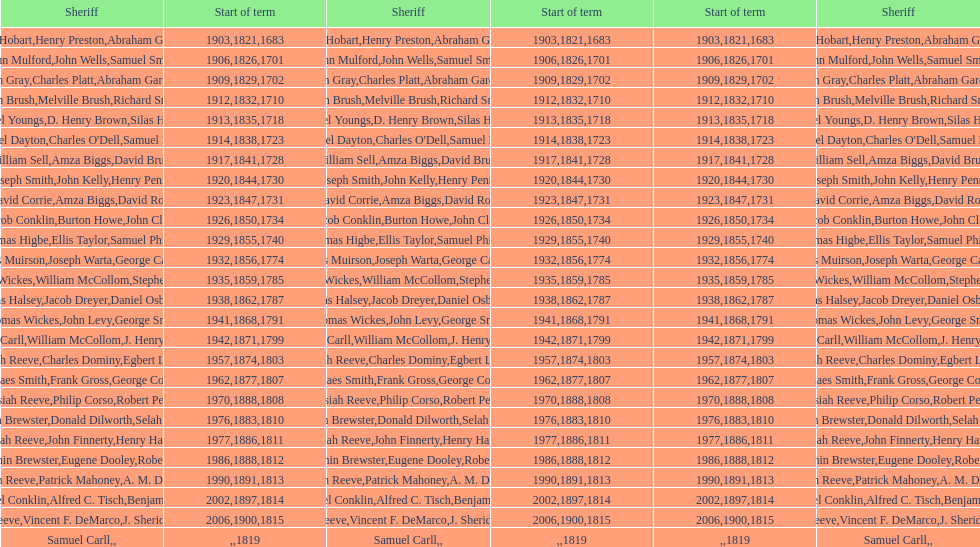Who was the sheriff in suffolk county before amza biggs first term there as sheriff? Charles O'Dell. Would you mind parsing the complete table? {'header': ['Sheriff', 'Start of term', 'Sheriff', 'Start of term', 'Start of term', 'Sheriff'], 'rows': [['Josiah Hobart', '1903', 'Henry Preston', '1821', '1683', 'Abraham Gardiner'], ['John Mulford', '1906', 'John Wells', '1826', '1701', 'Samuel Smith'], ['Hugh Gray', '1909', 'Charles Platt', '1829', '1702', 'Abraham Gardiner'], ['John Brush', '1912', 'Melville Brush', '1832', '1710', 'Richard Smith'], ['Daniel Youngs', '1913', 'D. Henry Brown', '1835', '1718', 'Silas Horton'], ['Samuel Dayton', '1914', "Charles O'Dell", '1838', '1723', 'Samuel Miller'], ['William Sell', '1917', 'Amza Biggs', '1841', '1728', 'David Brush'], ['Joseph Smith', '1920', 'John Kelly', '1844', '1730', 'Henry Penny'], ['David Corrie', '1923', 'Amza Biggs', '1847', '1731', 'David Rose'], ['Jacob Conklin', '1926', 'Burton Howe', '1850', '1734', 'John Clark'], ['Thomas Higbe', '1929', 'Ellis Taylor', '1855', '1740', 'Samuel Phillips'], ['James Muirson', '1932', 'Joseph Warta', '1856', '1774', 'George Carman'], ['Thomas Wickes', '1935', 'William McCollom', '1859', '1785', 'Stephen Wilson'], ['Silas Halsey', '1938', 'Jacob Dreyer', '1862', '1787', 'Daniel Osborn'], ['Thomas Wickes', '1941', 'John Levy', '1868', '1791', 'George Smith'], ['Phinaes Carll', '1942', 'William McCollom', '1871', '1799', 'J. Henry Perkins'], ['Josiah Reeve', '1957', 'Charles Dominy', '1874', '1803', 'Egbert Lewis'], ['Phinaes Smith', '1962', 'Frank Gross', '1877', '1807', 'George Cooper'], ['Josiah Reeve', '1970', 'Philip Corso', '1888', '1808', 'Robert Petty'], ['Benjamin Brewster', '1976', 'Donald Dilworth', '1883', '1810', 'Selah Brewster'], ['Josiah Reeve', '1977', 'John Finnerty', '1886', '1811', 'Henry Halsey'], ['Benjamin Brewster', '1986', 'Eugene Dooley', '1888', '1812', 'Robert Petty'], ['Josiah Reeve', '1990', 'Patrick Mahoney', '1891', '1813', 'A. M. Darling'], ['Nathaniel Conklin', '2002', 'Alfred C. Tisch', '1897', '1814', 'Benjamin Wood'], ['Josiah Reeve', '2006', 'Vincent F. DeMarco', '1900', '1815', 'J. Sheridan Wells'], ['Samuel Carll', '', '', '', '1819', '']]} 